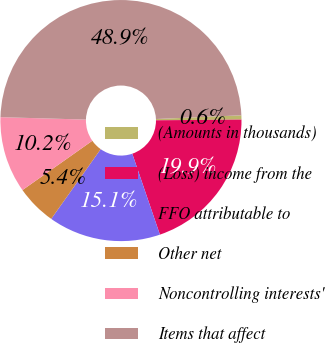Convert chart. <chart><loc_0><loc_0><loc_500><loc_500><pie_chart><fcel>(Amounts in thousands)<fcel>(Loss) income from the<fcel>FFO attributable to<fcel>Other net<fcel>Noncontrolling interests'<fcel>Items that affect<nl><fcel>0.57%<fcel>19.89%<fcel>15.06%<fcel>5.4%<fcel>10.23%<fcel>48.86%<nl></chart> 